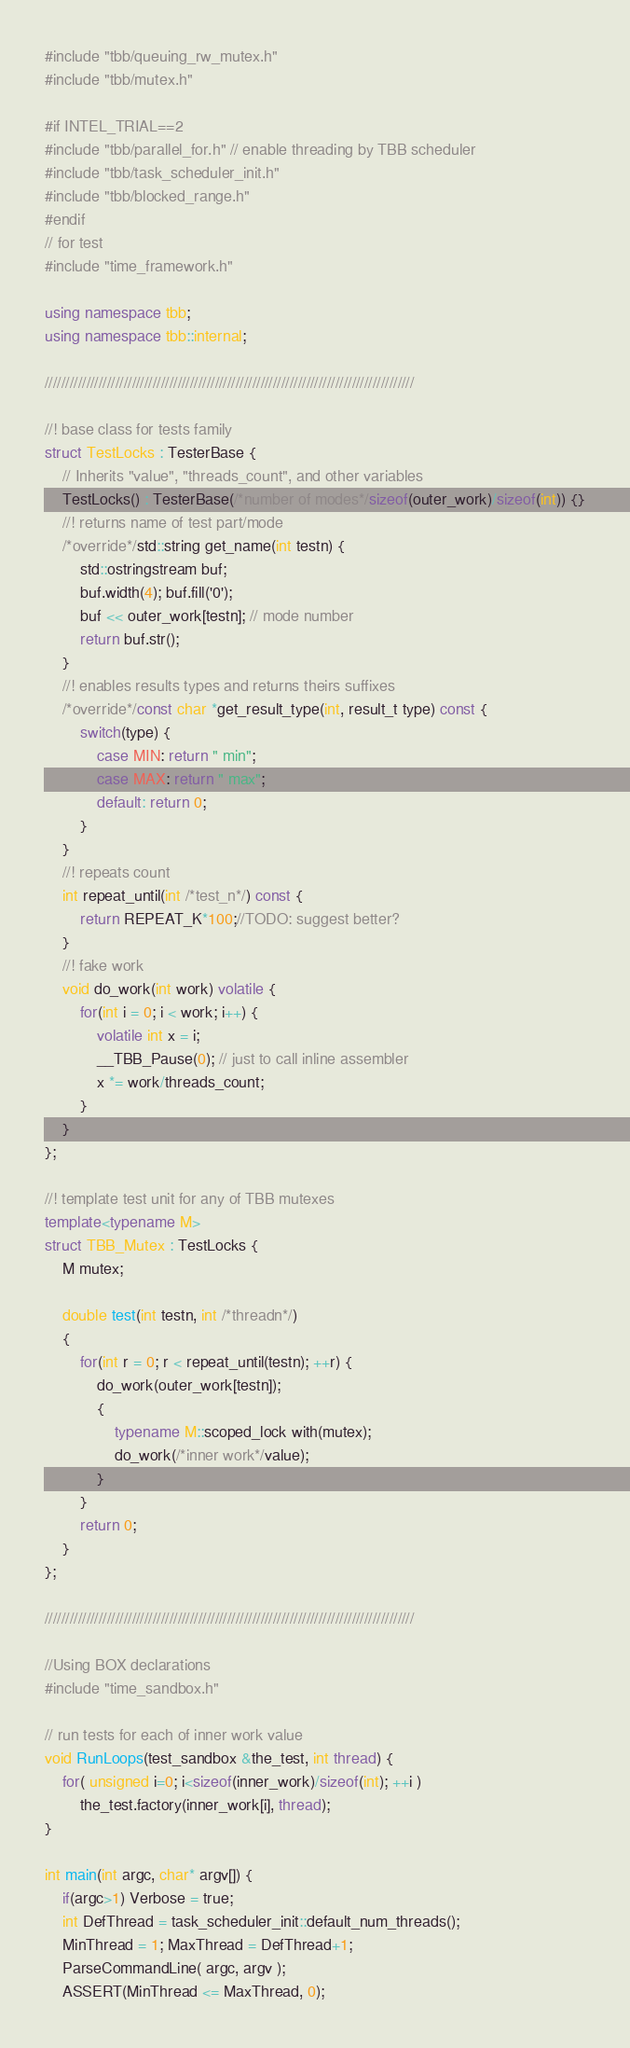<code> <loc_0><loc_0><loc_500><loc_500><_C++_>#include "tbb/queuing_rw_mutex.h"
#include "tbb/mutex.h"

#if INTEL_TRIAL==2
#include "tbb/parallel_for.h" // enable threading by TBB scheduler
#include "tbb/task_scheduler_init.h"
#include "tbb/blocked_range.h" 
#endif
// for test
#include "time_framework.h"

using namespace tbb;
using namespace tbb::internal;

/////////////////////////////////////////////////////////////////////////////////////////

//! base class for tests family
struct TestLocks : TesterBase {
    // Inherits "value", "threads_count", and other variables
    TestLocks() : TesterBase(/*number of modes*/sizeof(outer_work)/sizeof(int)) {}
    //! returns name of test part/mode
    /*override*/std::string get_name(int testn) {
        std::ostringstream buf;
        buf.width(4); buf.fill('0');
        buf << outer_work[testn]; // mode number
        return buf.str();
    }
    //! enables results types and returns theirs suffixes
    /*override*/const char *get_result_type(int, result_t type) const {
        switch(type) {
            case MIN: return " min";
            case MAX: return " max";
            default: return 0;
        }
    }
    //! repeats count
    int repeat_until(int /*test_n*/) const {
        return REPEAT_K*100;//TODO: suggest better?
    }
    //! fake work
    void do_work(int work) volatile {
        for(int i = 0; i < work; i++) {
            volatile int x = i;
            __TBB_Pause(0); // just to call inline assembler
            x *= work/threads_count;
        }
    }
};

//! template test unit for any of TBB mutexes
template<typename M>
struct TBB_Mutex : TestLocks {
    M mutex;

    double test(int testn, int /*threadn*/)
    {
        for(int r = 0; r < repeat_until(testn); ++r) {
            do_work(outer_work[testn]);
            {
                typename M::scoped_lock with(mutex);
                do_work(/*inner work*/value);
            }
        }
        return 0;
    }
};

/////////////////////////////////////////////////////////////////////////////////////////

//Using BOX declarations
#include "time_sandbox.h"

// run tests for each of inner work value
void RunLoops(test_sandbox &the_test, int thread) {
    for( unsigned i=0; i<sizeof(inner_work)/sizeof(int); ++i )
        the_test.factory(inner_work[i], thread);
}

int main(int argc, char* argv[]) {
    if(argc>1) Verbose = true;
    int DefThread = task_scheduler_init::default_num_threads();
    MinThread = 1; MaxThread = DefThread+1;
    ParseCommandLine( argc, argv );
    ASSERT(MinThread <= MaxThread, 0);</code> 